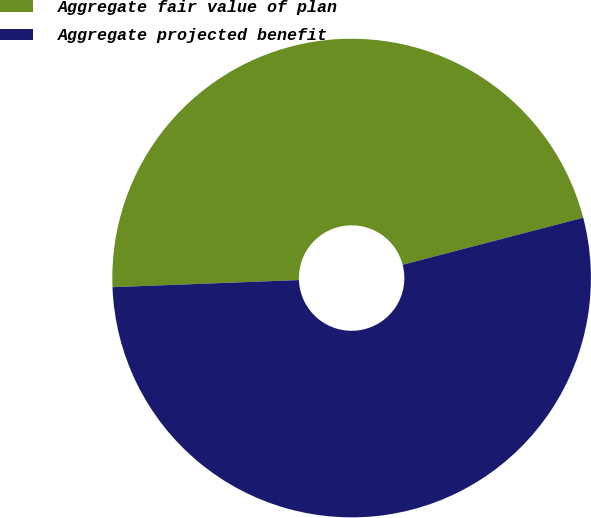Convert chart. <chart><loc_0><loc_0><loc_500><loc_500><pie_chart><fcel>Aggregate fair value of plan<fcel>Aggregate projected benefit<nl><fcel>46.55%<fcel>53.45%<nl></chart> 